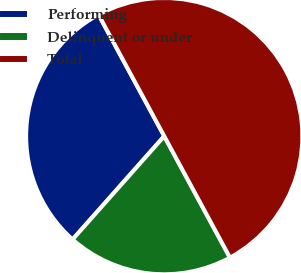Convert chart. <chart><loc_0><loc_0><loc_500><loc_500><pie_chart><fcel>Performing<fcel>Delinquent or under<fcel>Total<nl><fcel>30.56%<fcel>19.44%<fcel>50.0%<nl></chart> 